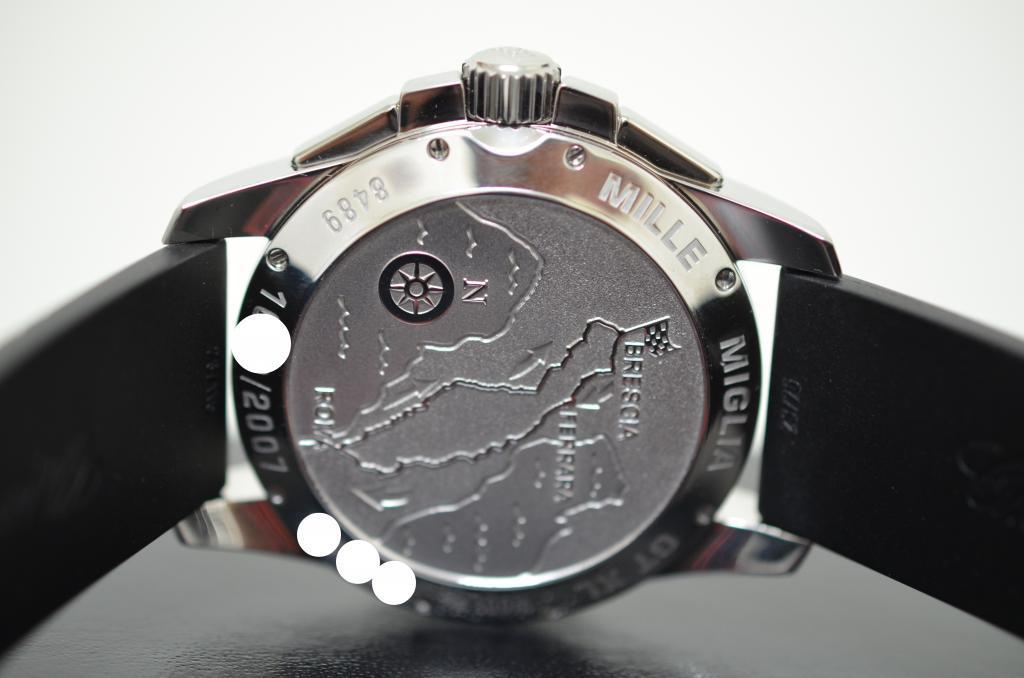<image>
Present a compact description of the photo's key features. The back of a silver watch face made by Mille 